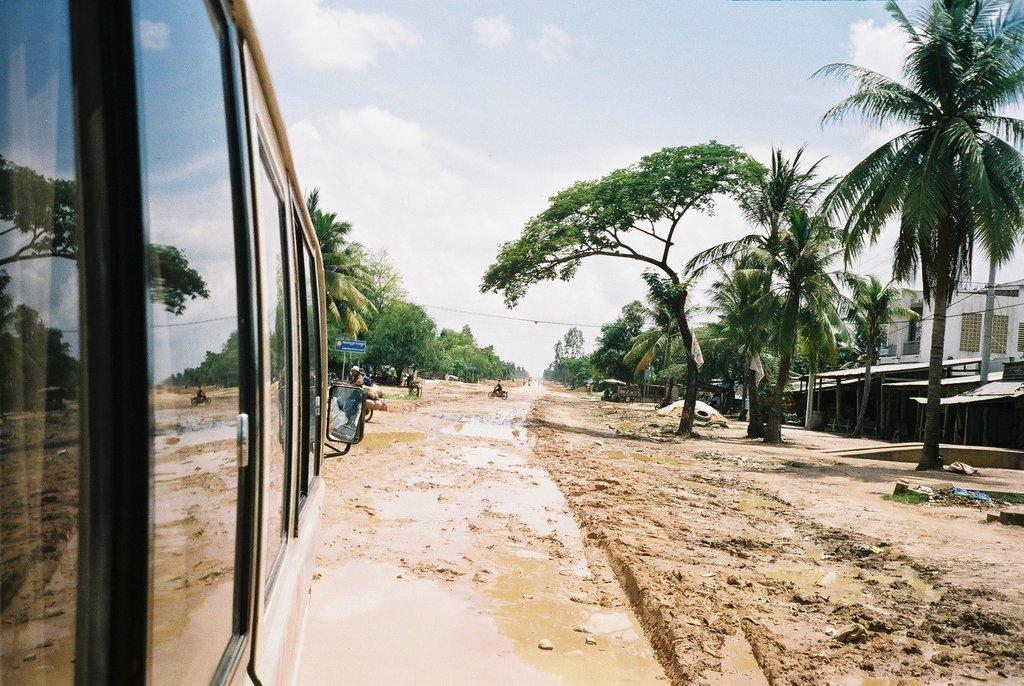What is the main subject of the image? There is a bus in the image. What is the condition of the area around the bus? There is a lot of mud around the bus. What type of natural elements can be seen in the image? There are trees in the image. What type of man-made structures are visible in the image? There are buildings in the image. What type of cracker is being used to fix the clock on the bus in the image? There is no cracker or clock present in the image. How much powder is visible on the ground near the bus in the image? There is no powder visible on the ground near the bus in the image. 